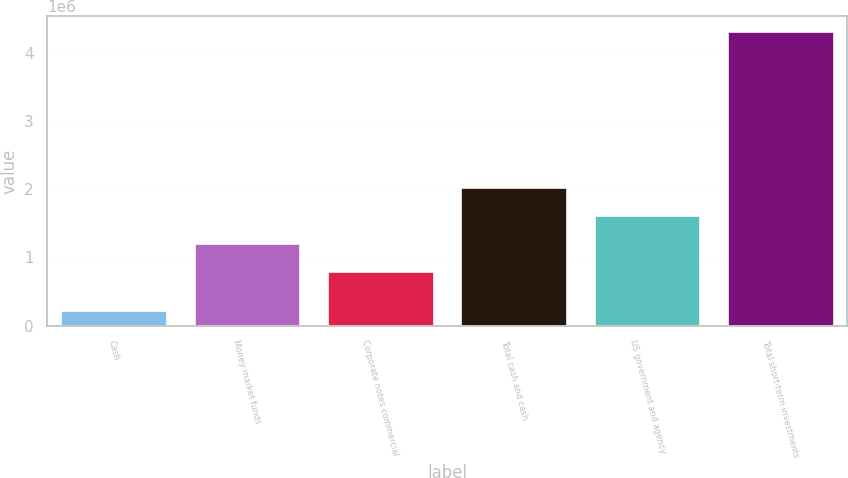<chart> <loc_0><loc_0><loc_500><loc_500><bar_chart><fcel>Cash<fcel>Money market funds<fcel>Corporate notes commercial<fcel>Total cash and cash<fcel>US government and agency<fcel>Total short-term investments<nl><fcel>229924<fcel>1.21182e+06<fcel>803314<fcel>2.02882e+06<fcel>1.62032e+06<fcel>4.31496e+06<nl></chart> 